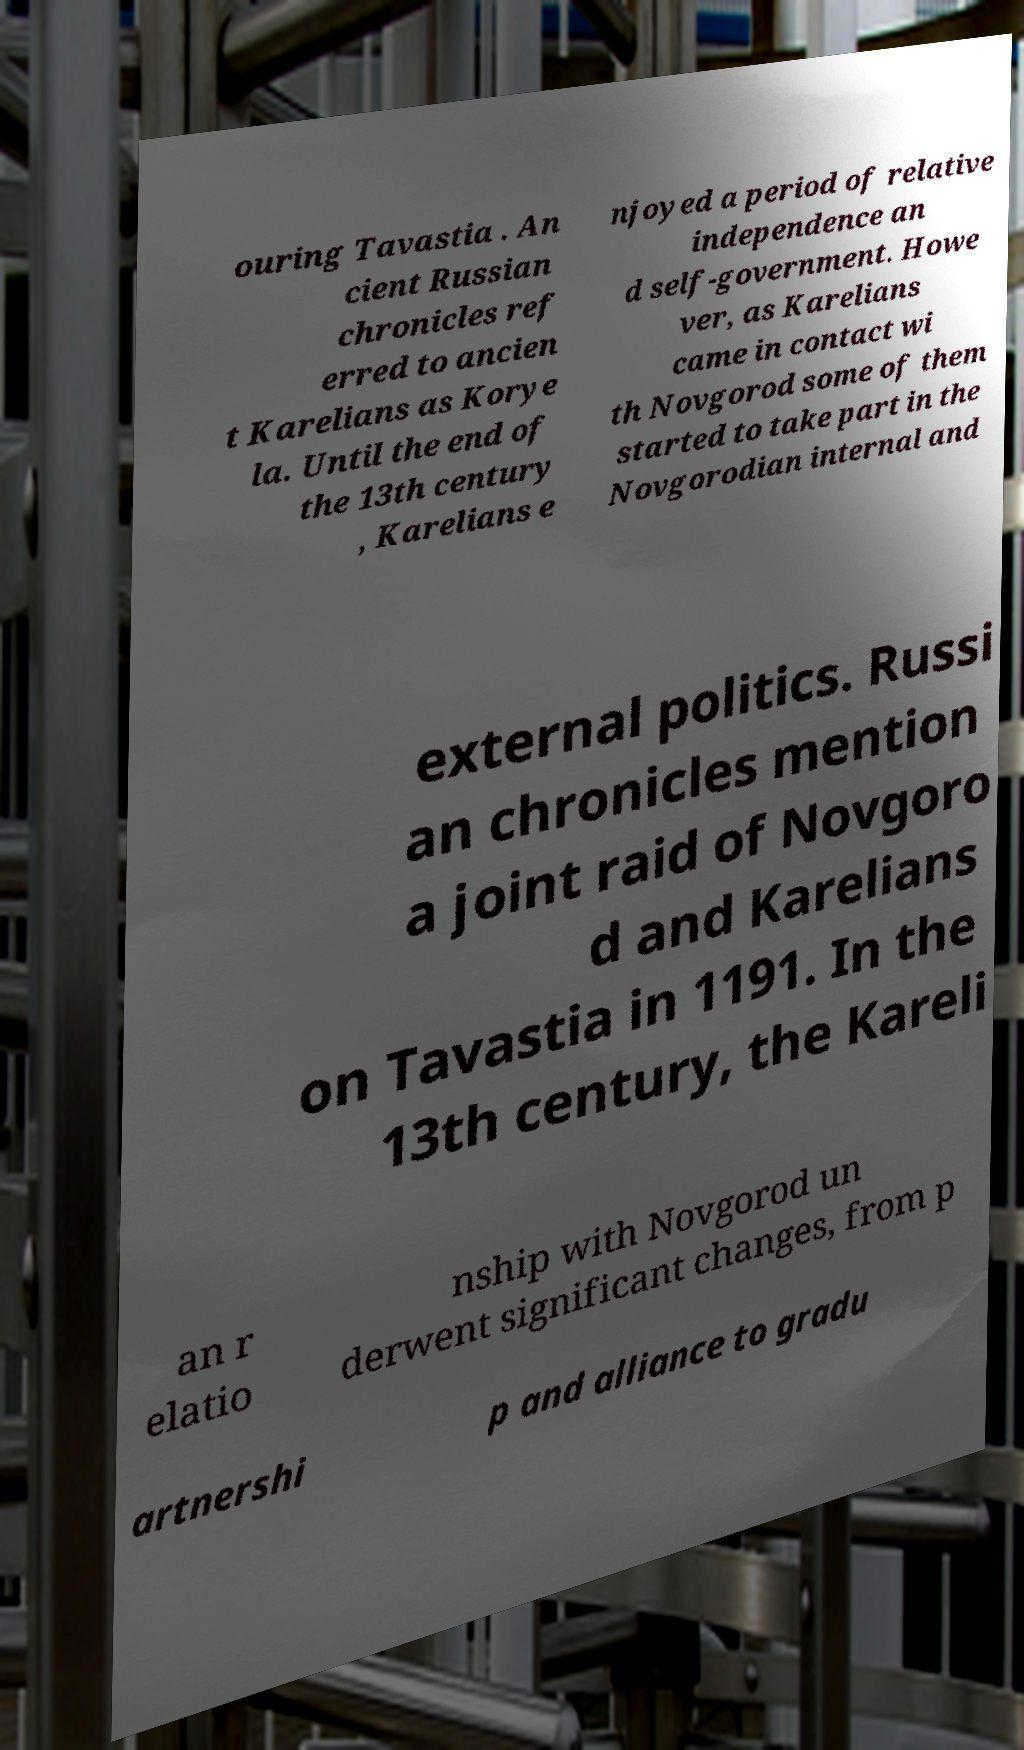What messages or text are displayed in this image? I need them in a readable, typed format. ouring Tavastia . An cient Russian chronicles ref erred to ancien t Karelians as Korye la. Until the end of the 13th century , Karelians e njoyed a period of relative independence an d self-government. Howe ver, as Karelians came in contact wi th Novgorod some of them started to take part in the Novgorodian internal and external politics. Russi an chronicles mention a joint raid of Novgoro d and Karelians on Tavastia in 1191. In the 13th century, the Kareli an r elatio nship with Novgorod un derwent significant changes, from p artnershi p and alliance to gradu 